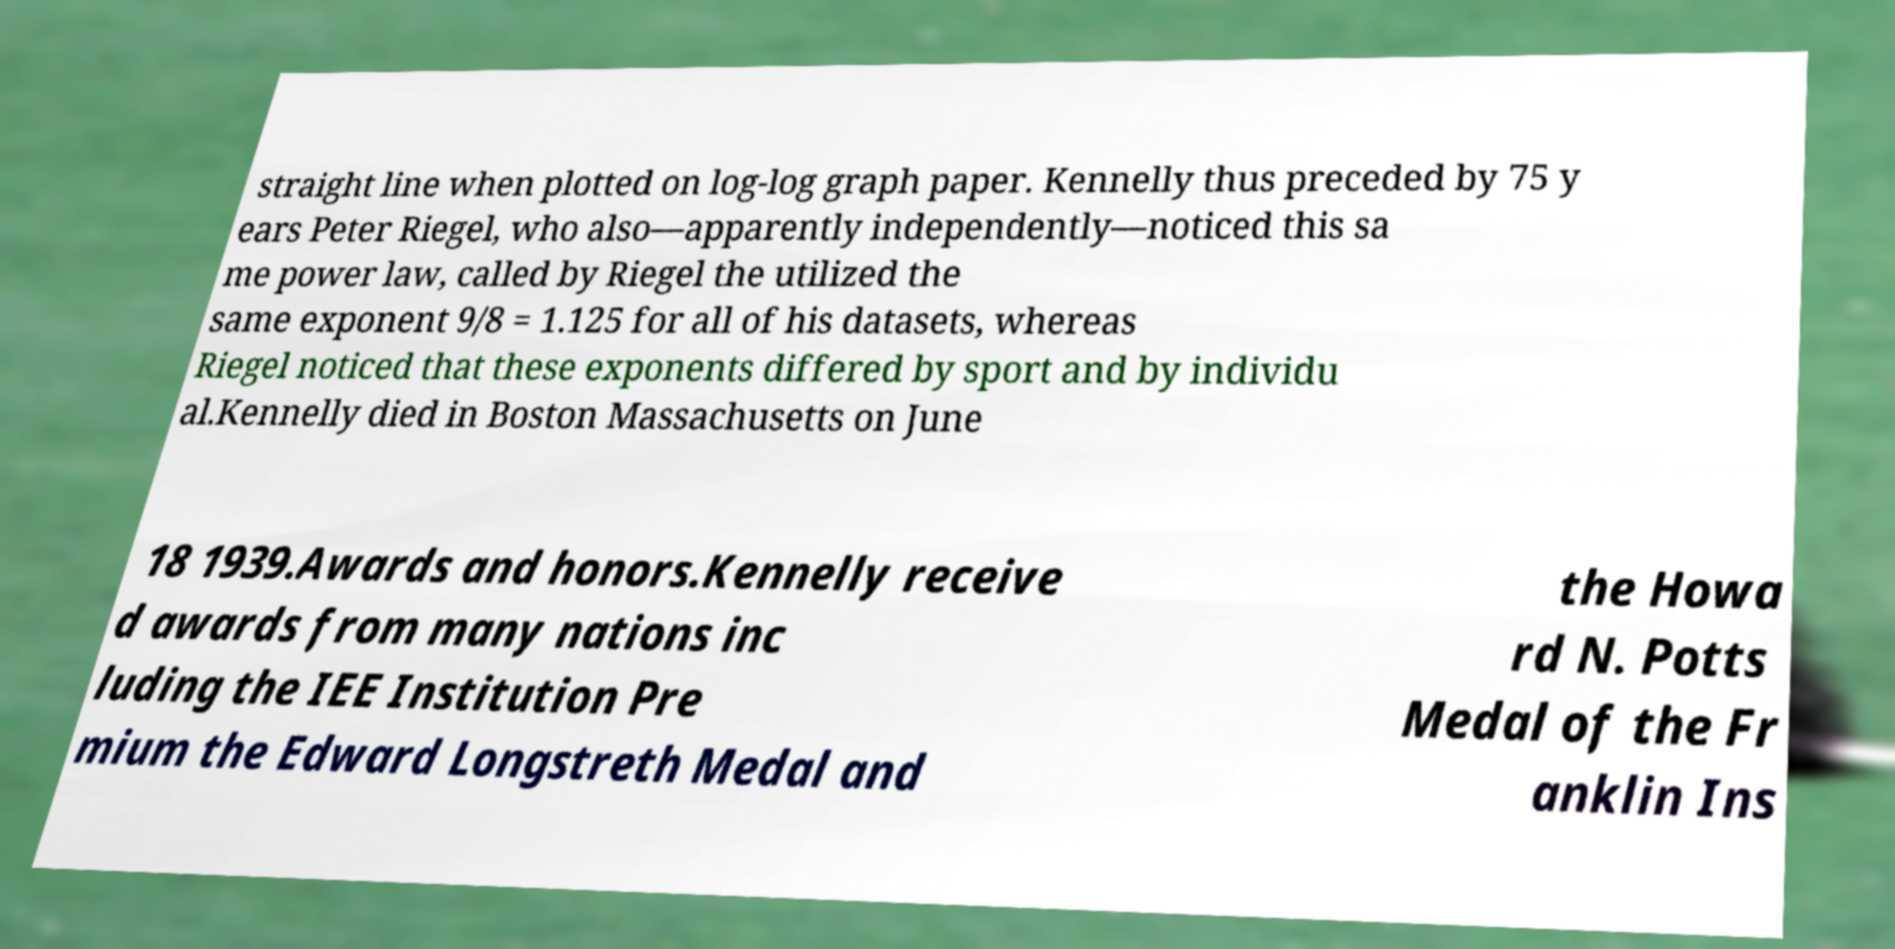Could you extract and type out the text from this image? straight line when plotted on log-log graph paper. Kennelly thus preceded by 75 y ears Peter Riegel, who also—apparently independently—noticed this sa me power law, called by Riegel the utilized the same exponent 9/8 = 1.125 for all of his datasets, whereas Riegel noticed that these exponents differed by sport and by individu al.Kennelly died in Boston Massachusetts on June 18 1939.Awards and honors.Kennelly receive d awards from many nations inc luding the IEE Institution Pre mium the Edward Longstreth Medal and the Howa rd N. Potts Medal of the Fr anklin Ins 